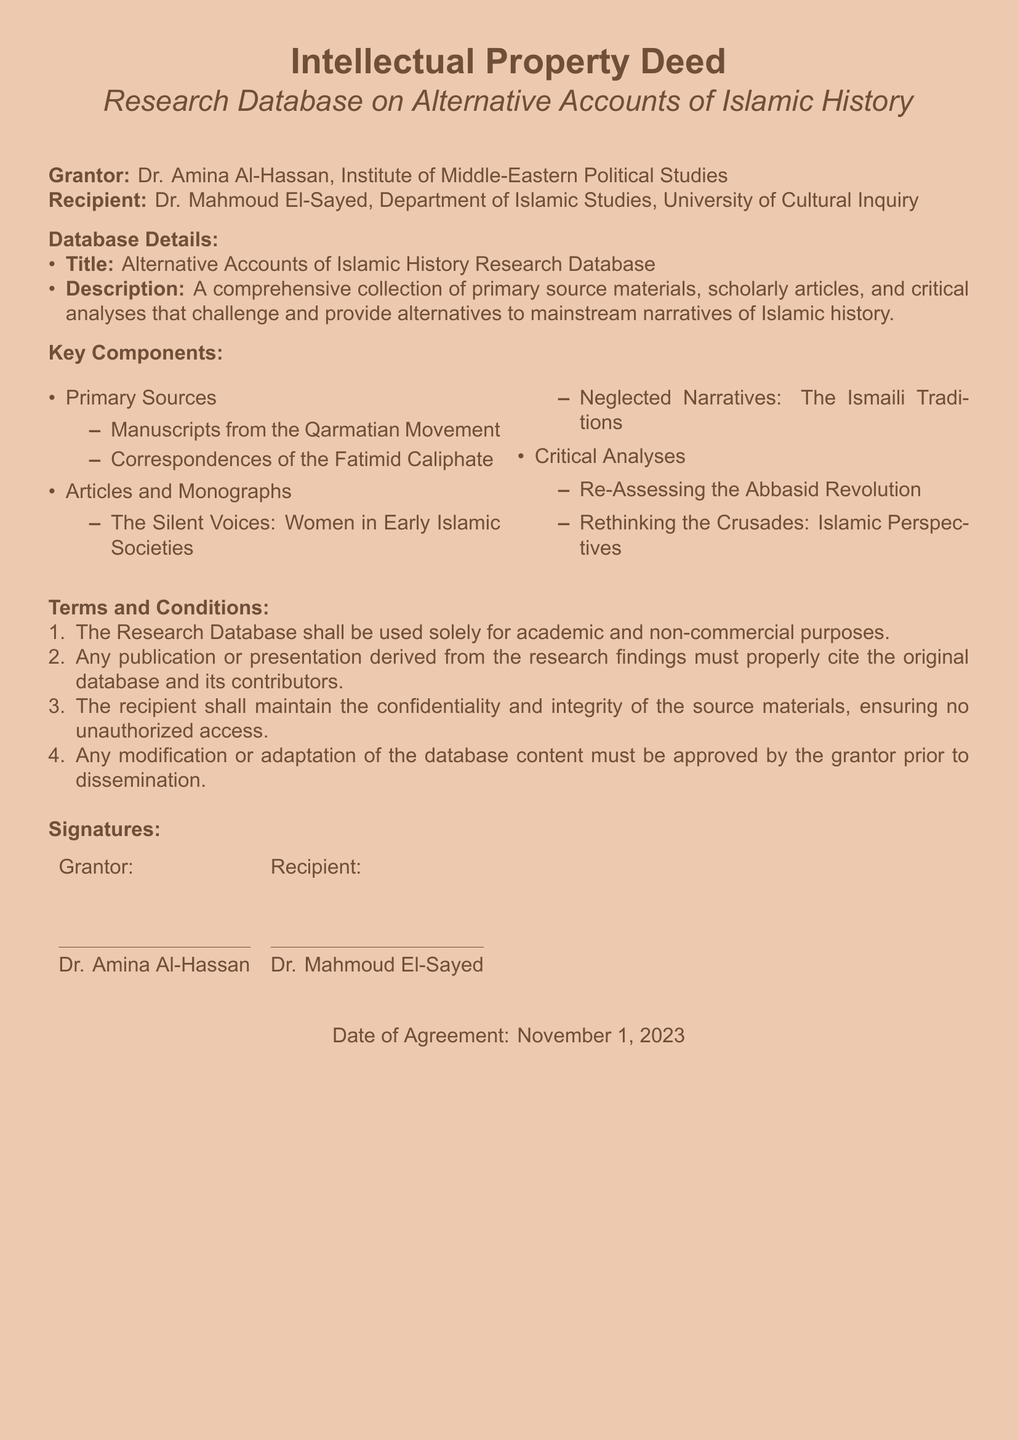What is the title of the database? The title of the database is mentioned in the document as "Alternative Accounts of Islamic History Research Database."
Answer: Alternative Accounts of Islamic History Research Database Who is the grantor of the deed? The document states that the grantor is Dr. Amina Al-Hassan.
Answer: Dr. Amina Al-Hassan What is the main purpose of the research database? The document describes the main purpose as a collection that challenges mainstream narratives of Islamic history.
Answer: To challenge mainstream narratives of Islamic history When was the agreement signed? The date of the agreement is explicitly mentioned in the document.
Answer: November 1, 2023 What type of materials does the database contain? The document lists various types of materials, including primary sources, articles, and critical analyses.
Answer: Primary sources, articles, critical analyses How many key components are listed in the document? The document provides a list of key components, which can be counted.
Answer: Three What must be maintained according to the terms and conditions? The terms require maintaining confidentiality and integrity of the source materials.
Answer: Confidentiality and integrity Is commercial use allowed for the database? The terms and conditions specify that the database can only be used for academic and non-commercial purposes.
Answer: No What modifications are allowed without approval? The document states that any modification or adaptation must be approved by the grantor prior to dissemination.
Answer: None without approval 